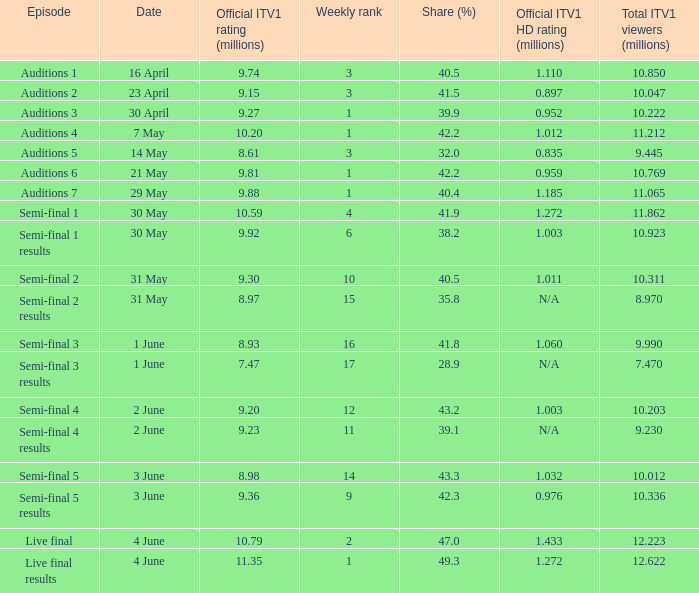What was the official ITV1 rating in millions of the Live Final Results episode? 11.35. 